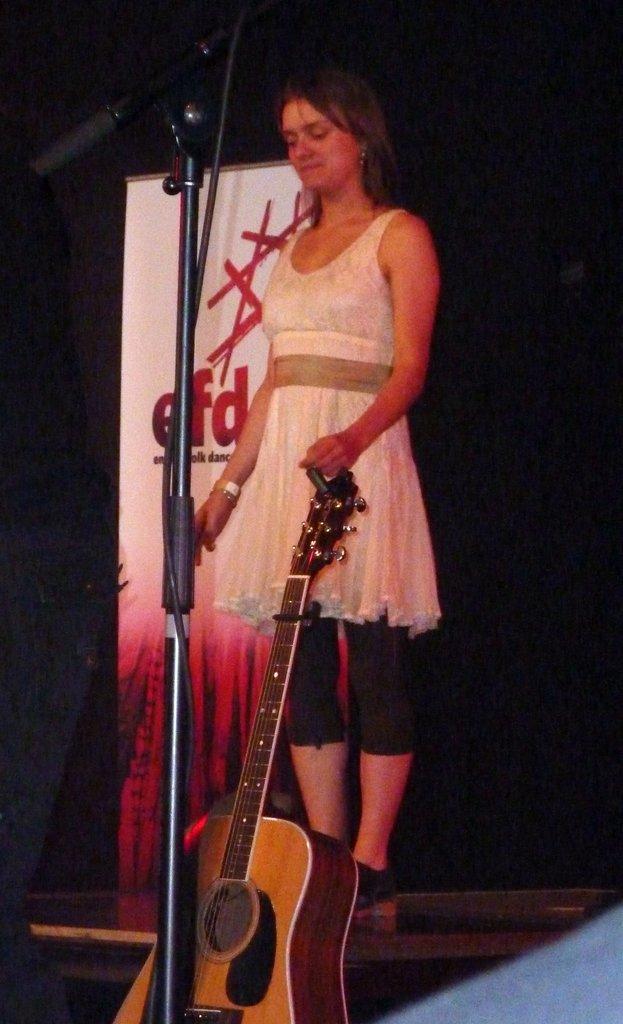How would you summarize this image in a sentence or two? here in this picture we can see a girl catching a guitar and standing in front of a micro phone,there is banner near the girl. 